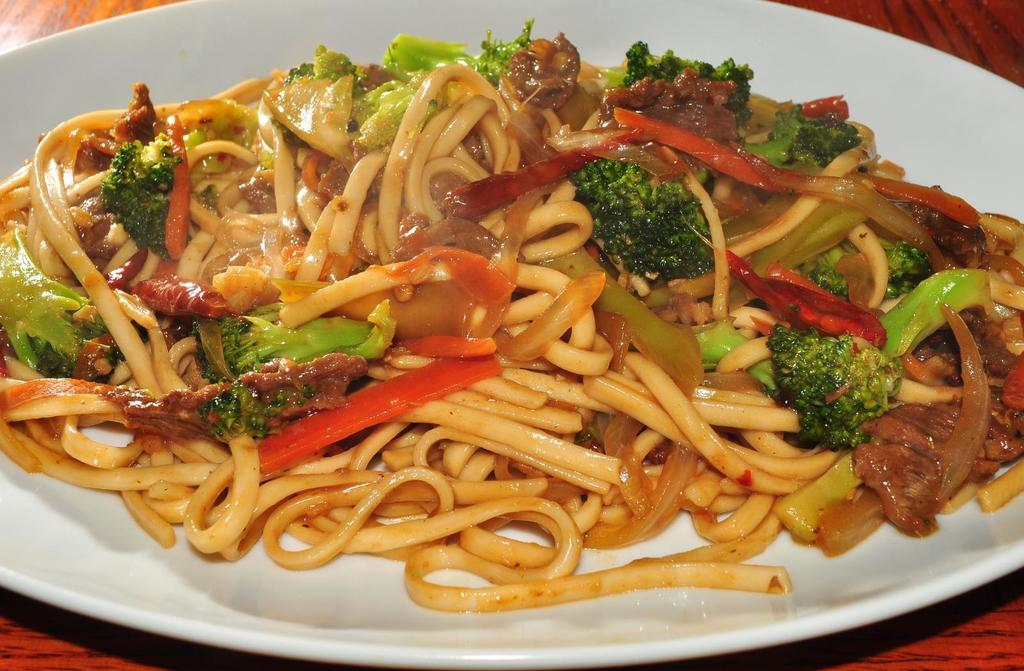What type of food can be seen in the image? There are noodles and broccoli in the image. Are there any other food items visible? Yes, there are other food items in the image. How are the food items arranged? The food items are on a plate. What is the plate placed on? The plate is on a wooden table. Can you see any bones sticking out of the noodles in the image? There are no bones visible in the image; it features noodles and broccoli on a plate. Is there a bat flying around the food items in the image? There is no bat present in the image; it only shows food items on a plate. 